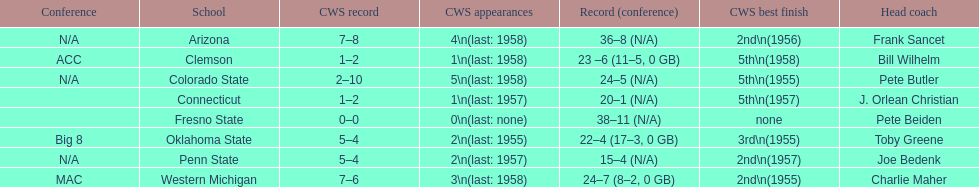Which was the only team with less than 20 wins? Penn State. 